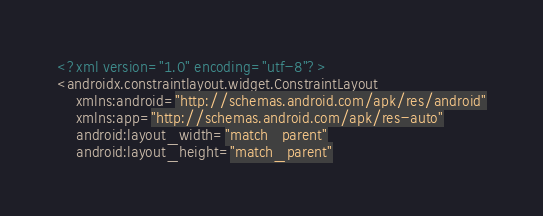<code> <loc_0><loc_0><loc_500><loc_500><_XML_><?xml version="1.0" encoding="utf-8"?>
<androidx.constraintlayout.widget.ConstraintLayout
    xmlns:android="http://schemas.android.com/apk/res/android"
    xmlns:app="http://schemas.android.com/apk/res-auto"
    android:layout_width="match_parent"
    android:layout_height="match_parent"</code> 